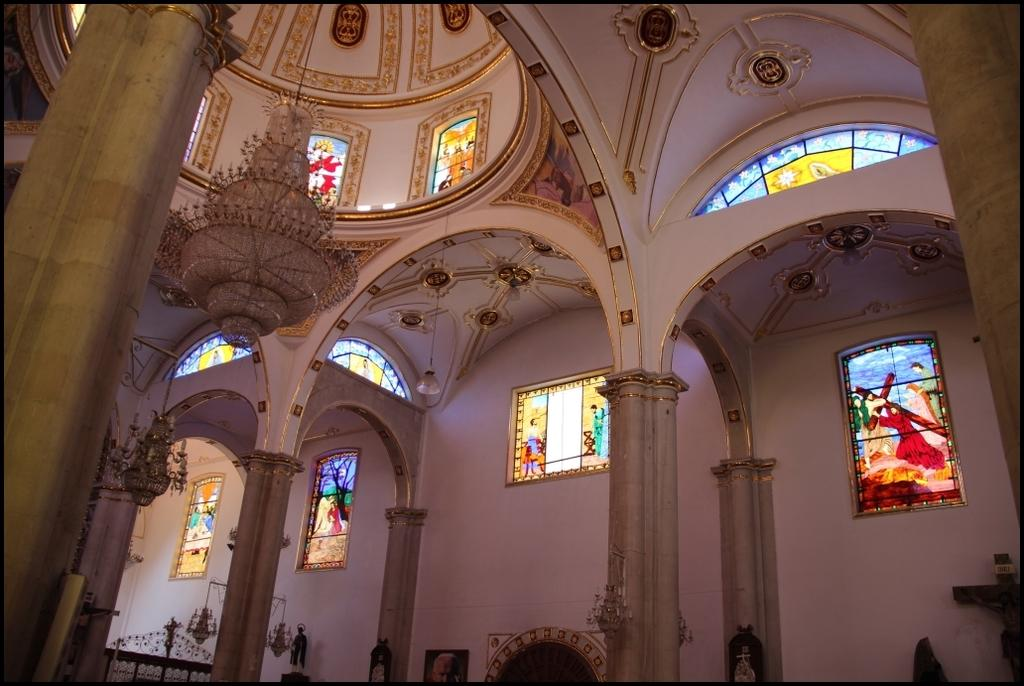What type of location is depicted in the image? The image shows an inside view of a building. What specific architectural feature can be seen in the image? There are stained glasses and pillars present in the image. What lighting fixture is visible in the image? A chandelier is visible in the image. What can be seen in the background of the image? There is a wall in the background of the image. How does the ship navigate through the force of the wind in the image? There is no ship present in the image; it depicts an inside view of a building with stained glasses, a chandelier, and pillars. What color is the nose of the person in the image? There are no people or noses visible in the image. 